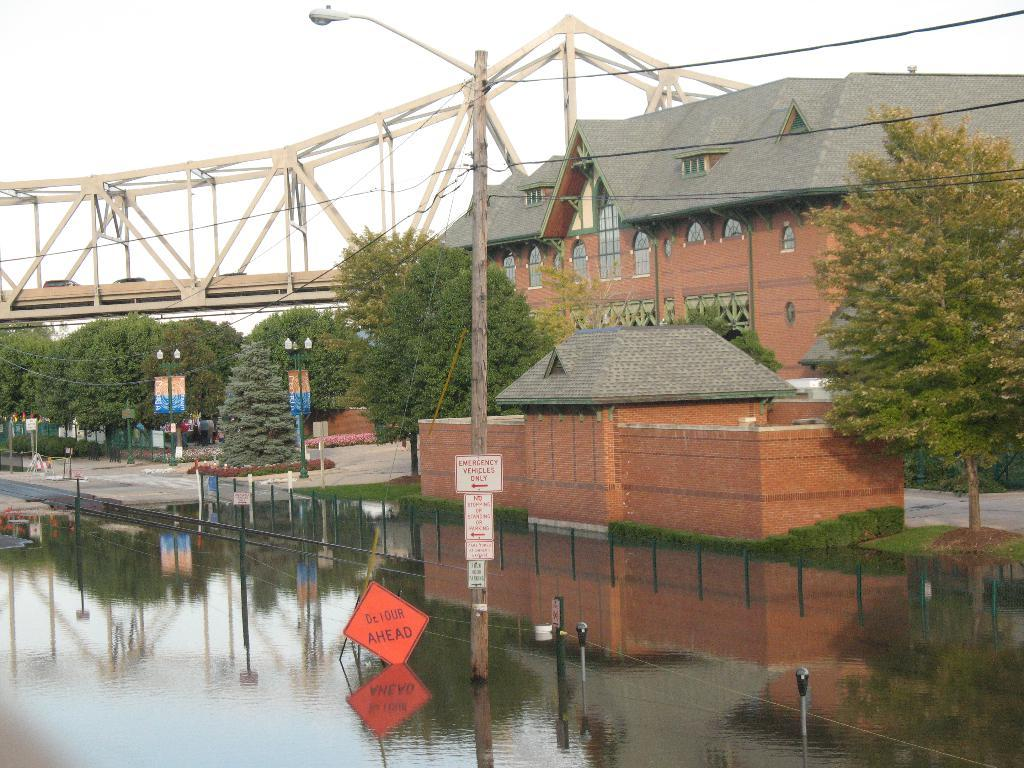What is the primary element visible in the image? There is water in the image. What structures can be seen in the image? There are sign boards and poles in the image. What can be seen in the background of the image? There are trees, buildings, lights, and a bridge in the background of the image. What type of government is depicted on the sign boards in the image? There is no indication of a government on the sign boards in the image; they are simply sign boards. 